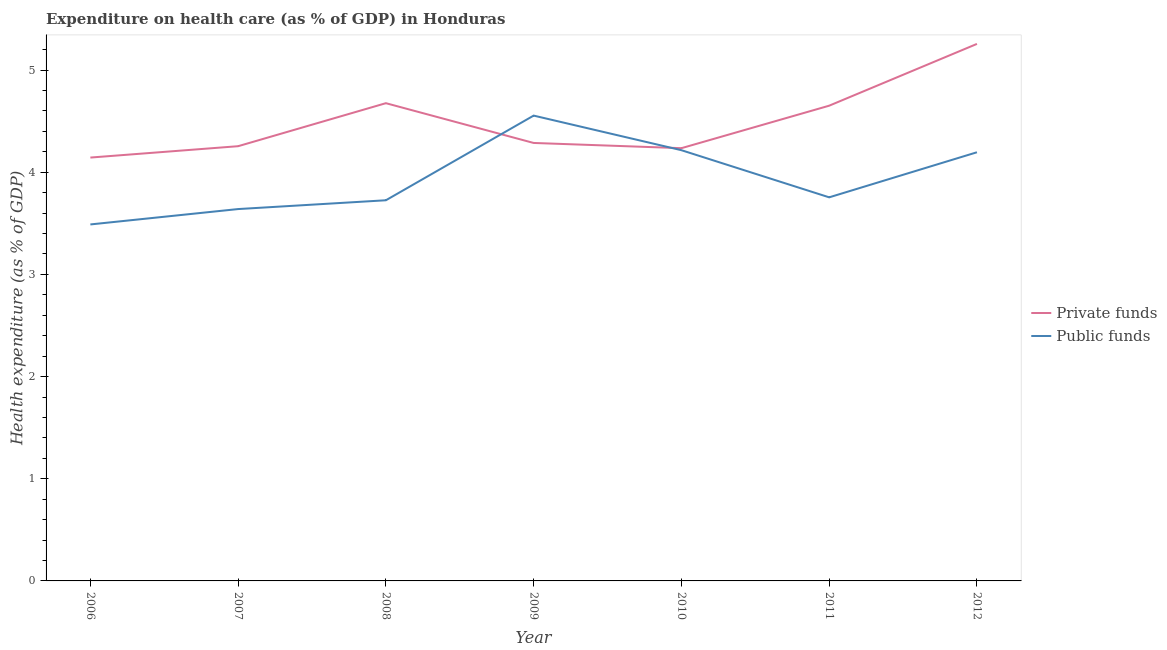How many different coloured lines are there?
Your answer should be compact. 2. Is the number of lines equal to the number of legend labels?
Make the answer very short. Yes. What is the amount of public funds spent in healthcare in 2011?
Ensure brevity in your answer.  3.75. Across all years, what is the maximum amount of public funds spent in healthcare?
Your response must be concise. 4.55. Across all years, what is the minimum amount of public funds spent in healthcare?
Keep it short and to the point. 3.49. In which year was the amount of public funds spent in healthcare maximum?
Ensure brevity in your answer.  2009. What is the total amount of public funds spent in healthcare in the graph?
Offer a terse response. 27.57. What is the difference between the amount of private funds spent in healthcare in 2009 and that in 2012?
Give a very brief answer. -0.97. What is the difference between the amount of private funds spent in healthcare in 2012 and the amount of public funds spent in healthcare in 2008?
Your answer should be very brief. 1.53. What is the average amount of public funds spent in healthcare per year?
Provide a short and direct response. 3.94. In the year 2007, what is the difference between the amount of public funds spent in healthcare and amount of private funds spent in healthcare?
Offer a terse response. -0.62. In how many years, is the amount of public funds spent in healthcare greater than 3 %?
Offer a terse response. 7. What is the ratio of the amount of public funds spent in healthcare in 2007 to that in 2010?
Make the answer very short. 0.86. What is the difference between the highest and the second highest amount of private funds spent in healthcare?
Offer a very short reply. 0.58. What is the difference between the highest and the lowest amount of private funds spent in healthcare?
Your answer should be compact. 1.11. In how many years, is the amount of public funds spent in healthcare greater than the average amount of public funds spent in healthcare taken over all years?
Provide a succinct answer. 3. Is the amount of private funds spent in healthcare strictly greater than the amount of public funds spent in healthcare over the years?
Offer a terse response. No. What is the difference between two consecutive major ticks on the Y-axis?
Your answer should be compact. 1. Are the values on the major ticks of Y-axis written in scientific E-notation?
Provide a succinct answer. No. Does the graph contain any zero values?
Offer a very short reply. No. What is the title of the graph?
Make the answer very short. Expenditure on health care (as % of GDP) in Honduras. Does "Unregistered firms" appear as one of the legend labels in the graph?
Your answer should be very brief. No. What is the label or title of the Y-axis?
Your answer should be very brief. Health expenditure (as % of GDP). What is the Health expenditure (as % of GDP) in Private funds in 2006?
Your answer should be very brief. 4.14. What is the Health expenditure (as % of GDP) in Public funds in 2006?
Your answer should be very brief. 3.49. What is the Health expenditure (as % of GDP) of Private funds in 2007?
Your answer should be very brief. 4.25. What is the Health expenditure (as % of GDP) in Public funds in 2007?
Your response must be concise. 3.64. What is the Health expenditure (as % of GDP) in Private funds in 2008?
Give a very brief answer. 4.68. What is the Health expenditure (as % of GDP) of Public funds in 2008?
Provide a succinct answer. 3.73. What is the Health expenditure (as % of GDP) in Private funds in 2009?
Provide a short and direct response. 4.29. What is the Health expenditure (as % of GDP) in Public funds in 2009?
Give a very brief answer. 4.55. What is the Health expenditure (as % of GDP) in Private funds in 2010?
Your answer should be compact. 4.24. What is the Health expenditure (as % of GDP) in Public funds in 2010?
Give a very brief answer. 4.22. What is the Health expenditure (as % of GDP) of Private funds in 2011?
Your answer should be very brief. 4.65. What is the Health expenditure (as % of GDP) in Public funds in 2011?
Provide a succinct answer. 3.75. What is the Health expenditure (as % of GDP) of Private funds in 2012?
Your answer should be very brief. 5.26. What is the Health expenditure (as % of GDP) of Public funds in 2012?
Your response must be concise. 4.2. Across all years, what is the maximum Health expenditure (as % of GDP) in Private funds?
Your answer should be very brief. 5.26. Across all years, what is the maximum Health expenditure (as % of GDP) of Public funds?
Provide a succinct answer. 4.55. Across all years, what is the minimum Health expenditure (as % of GDP) in Private funds?
Provide a succinct answer. 4.14. Across all years, what is the minimum Health expenditure (as % of GDP) in Public funds?
Provide a short and direct response. 3.49. What is the total Health expenditure (as % of GDP) of Private funds in the graph?
Your response must be concise. 31.5. What is the total Health expenditure (as % of GDP) of Public funds in the graph?
Offer a very short reply. 27.57. What is the difference between the Health expenditure (as % of GDP) of Private funds in 2006 and that in 2007?
Your response must be concise. -0.11. What is the difference between the Health expenditure (as % of GDP) of Public funds in 2006 and that in 2007?
Make the answer very short. -0.15. What is the difference between the Health expenditure (as % of GDP) of Private funds in 2006 and that in 2008?
Your answer should be very brief. -0.53. What is the difference between the Health expenditure (as % of GDP) in Public funds in 2006 and that in 2008?
Offer a terse response. -0.24. What is the difference between the Health expenditure (as % of GDP) in Private funds in 2006 and that in 2009?
Your response must be concise. -0.14. What is the difference between the Health expenditure (as % of GDP) of Public funds in 2006 and that in 2009?
Your answer should be very brief. -1.07. What is the difference between the Health expenditure (as % of GDP) in Private funds in 2006 and that in 2010?
Offer a terse response. -0.09. What is the difference between the Health expenditure (as % of GDP) of Public funds in 2006 and that in 2010?
Ensure brevity in your answer.  -0.73. What is the difference between the Health expenditure (as % of GDP) in Private funds in 2006 and that in 2011?
Your response must be concise. -0.51. What is the difference between the Health expenditure (as % of GDP) of Public funds in 2006 and that in 2011?
Provide a succinct answer. -0.27. What is the difference between the Health expenditure (as % of GDP) of Private funds in 2006 and that in 2012?
Make the answer very short. -1.11. What is the difference between the Health expenditure (as % of GDP) of Public funds in 2006 and that in 2012?
Ensure brevity in your answer.  -0.71. What is the difference between the Health expenditure (as % of GDP) of Private funds in 2007 and that in 2008?
Your answer should be compact. -0.42. What is the difference between the Health expenditure (as % of GDP) of Public funds in 2007 and that in 2008?
Give a very brief answer. -0.09. What is the difference between the Health expenditure (as % of GDP) of Private funds in 2007 and that in 2009?
Offer a terse response. -0.03. What is the difference between the Health expenditure (as % of GDP) of Public funds in 2007 and that in 2009?
Your answer should be compact. -0.91. What is the difference between the Health expenditure (as % of GDP) in Private funds in 2007 and that in 2010?
Make the answer very short. 0.02. What is the difference between the Health expenditure (as % of GDP) of Public funds in 2007 and that in 2010?
Your answer should be compact. -0.58. What is the difference between the Health expenditure (as % of GDP) of Private funds in 2007 and that in 2011?
Offer a very short reply. -0.4. What is the difference between the Health expenditure (as % of GDP) of Public funds in 2007 and that in 2011?
Keep it short and to the point. -0.11. What is the difference between the Health expenditure (as % of GDP) of Private funds in 2007 and that in 2012?
Make the answer very short. -1. What is the difference between the Health expenditure (as % of GDP) in Public funds in 2007 and that in 2012?
Provide a short and direct response. -0.56. What is the difference between the Health expenditure (as % of GDP) in Private funds in 2008 and that in 2009?
Ensure brevity in your answer.  0.39. What is the difference between the Health expenditure (as % of GDP) in Public funds in 2008 and that in 2009?
Keep it short and to the point. -0.83. What is the difference between the Health expenditure (as % of GDP) of Private funds in 2008 and that in 2010?
Your answer should be compact. 0.44. What is the difference between the Health expenditure (as % of GDP) of Public funds in 2008 and that in 2010?
Provide a succinct answer. -0.49. What is the difference between the Health expenditure (as % of GDP) of Private funds in 2008 and that in 2011?
Provide a succinct answer. 0.02. What is the difference between the Health expenditure (as % of GDP) of Public funds in 2008 and that in 2011?
Ensure brevity in your answer.  -0.03. What is the difference between the Health expenditure (as % of GDP) in Private funds in 2008 and that in 2012?
Give a very brief answer. -0.58. What is the difference between the Health expenditure (as % of GDP) of Public funds in 2008 and that in 2012?
Your response must be concise. -0.47. What is the difference between the Health expenditure (as % of GDP) of Private funds in 2009 and that in 2010?
Your response must be concise. 0.05. What is the difference between the Health expenditure (as % of GDP) in Public funds in 2009 and that in 2010?
Offer a very short reply. 0.34. What is the difference between the Health expenditure (as % of GDP) in Private funds in 2009 and that in 2011?
Provide a short and direct response. -0.36. What is the difference between the Health expenditure (as % of GDP) in Public funds in 2009 and that in 2011?
Keep it short and to the point. 0.8. What is the difference between the Health expenditure (as % of GDP) of Private funds in 2009 and that in 2012?
Offer a terse response. -0.97. What is the difference between the Health expenditure (as % of GDP) of Public funds in 2009 and that in 2012?
Provide a succinct answer. 0.36. What is the difference between the Health expenditure (as % of GDP) of Private funds in 2010 and that in 2011?
Your answer should be compact. -0.42. What is the difference between the Health expenditure (as % of GDP) in Public funds in 2010 and that in 2011?
Offer a very short reply. 0.46. What is the difference between the Health expenditure (as % of GDP) in Private funds in 2010 and that in 2012?
Offer a very short reply. -1.02. What is the difference between the Health expenditure (as % of GDP) in Public funds in 2010 and that in 2012?
Provide a succinct answer. 0.02. What is the difference between the Health expenditure (as % of GDP) in Private funds in 2011 and that in 2012?
Provide a short and direct response. -0.6. What is the difference between the Health expenditure (as % of GDP) of Public funds in 2011 and that in 2012?
Your answer should be very brief. -0.44. What is the difference between the Health expenditure (as % of GDP) of Private funds in 2006 and the Health expenditure (as % of GDP) of Public funds in 2007?
Provide a short and direct response. 0.5. What is the difference between the Health expenditure (as % of GDP) in Private funds in 2006 and the Health expenditure (as % of GDP) in Public funds in 2008?
Keep it short and to the point. 0.42. What is the difference between the Health expenditure (as % of GDP) in Private funds in 2006 and the Health expenditure (as % of GDP) in Public funds in 2009?
Your response must be concise. -0.41. What is the difference between the Health expenditure (as % of GDP) in Private funds in 2006 and the Health expenditure (as % of GDP) in Public funds in 2010?
Give a very brief answer. -0.07. What is the difference between the Health expenditure (as % of GDP) of Private funds in 2006 and the Health expenditure (as % of GDP) of Public funds in 2011?
Keep it short and to the point. 0.39. What is the difference between the Health expenditure (as % of GDP) of Private funds in 2006 and the Health expenditure (as % of GDP) of Public funds in 2012?
Provide a short and direct response. -0.05. What is the difference between the Health expenditure (as % of GDP) of Private funds in 2007 and the Health expenditure (as % of GDP) of Public funds in 2008?
Provide a succinct answer. 0.53. What is the difference between the Health expenditure (as % of GDP) in Private funds in 2007 and the Health expenditure (as % of GDP) in Public funds in 2009?
Offer a terse response. -0.3. What is the difference between the Health expenditure (as % of GDP) in Private funds in 2007 and the Health expenditure (as % of GDP) in Public funds in 2010?
Keep it short and to the point. 0.04. What is the difference between the Health expenditure (as % of GDP) of Private funds in 2007 and the Health expenditure (as % of GDP) of Public funds in 2011?
Your response must be concise. 0.5. What is the difference between the Health expenditure (as % of GDP) in Private funds in 2007 and the Health expenditure (as % of GDP) in Public funds in 2012?
Make the answer very short. 0.06. What is the difference between the Health expenditure (as % of GDP) of Private funds in 2008 and the Health expenditure (as % of GDP) of Public funds in 2009?
Offer a very short reply. 0.12. What is the difference between the Health expenditure (as % of GDP) of Private funds in 2008 and the Health expenditure (as % of GDP) of Public funds in 2010?
Your answer should be compact. 0.46. What is the difference between the Health expenditure (as % of GDP) of Private funds in 2008 and the Health expenditure (as % of GDP) of Public funds in 2011?
Keep it short and to the point. 0.92. What is the difference between the Health expenditure (as % of GDP) of Private funds in 2008 and the Health expenditure (as % of GDP) of Public funds in 2012?
Offer a very short reply. 0.48. What is the difference between the Health expenditure (as % of GDP) in Private funds in 2009 and the Health expenditure (as % of GDP) in Public funds in 2010?
Keep it short and to the point. 0.07. What is the difference between the Health expenditure (as % of GDP) in Private funds in 2009 and the Health expenditure (as % of GDP) in Public funds in 2011?
Give a very brief answer. 0.53. What is the difference between the Health expenditure (as % of GDP) in Private funds in 2009 and the Health expenditure (as % of GDP) in Public funds in 2012?
Your answer should be very brief. 0.09. What is the difference between the Health expenditure (as % of GDP) of Private funds in 2010 and the Health expenditure (as % of GDP) of Public funds in 2011?
Your answer should be compact. 0.48. What is the difference between the Health expenditure (as % of GDP) of Private funds in 2010 and the Health expenditure (as % of GDP) of Public funds in 2012?
Make the answer very short. 0.04. What is the difference between the Health expenditure (as % of GDP) in Private funds in 2011 and the Health expenditure (as % of GDP) in Public funds in 2012?
Provide a succinct answer. 0.46. What is the average Health expenditure (as % of GDP) in Private funds per year?
Provide a succinct answer. 4.5. What is the average Health expenditure (as % of GDP) in Public funds per year?
Make the answer very short. 3.94. In the year 2006, what is the difference between the Health expenditure (as % of GDP) of Private funds and Health expenditure (as % of GDP) of Public funds?
Provide a short and direct response. 0.65. In the year 2007, what is the difference between the Health expenditure (as % of GDP) of Private funds and Health expenditure (as % of GDP) of Public funds?
Give a very brief answer. 0.62. In the year 2008, what is the difference between the Health expenditure (as % of GDP) in Private funds and Health expenditure (as % of GDP) in Public funds?
Provide a short and direct response. 0.95. In the year 2009, what is the difference between the Health expenditure (as % of GDP) in Private funds and Health expenditure (as % of GDP) in Public funds?
Make the answer very short. -0.27. In the year 2010, what is the difference between the Health expenditure (as % of GDP) in Private funds and Health expenditure (as % of GDP) in Public funds?
Make the answer very short. 0.02. In the year 2011, what is the difference between the Health expenditure (as % of GDP) in Private funds and Health expenditure (as % of GDP) in Public funds?
Make the answer very short. 0.9. In the year 2012, what is the difference between the Health expenditure (as % of GDP) of Private funds and Health expenditure (as % of GDP) of Public funds?
Make the answer very short. 1.06. What is the ratio of the Health expenditure (as % of GDP) in Private funds in 2006 to that in 2007?
Offer a terse response. 0.97. What is the ratio of the Health expenditure (as % of GDP) in Public funds in 2006 to that in 2007?
Provide a short and direct response. 0.96. What is the ratio of the Health expenditure (as % of GDP) of Private funds in 2006 to that in 2008?
Ensure brevity in your answer.  0.89. What is the ratio of the Health expenditure (as % of GDP) of Public funds in 2006 to that in 2008?
Provide a succinct answer. 0.94. What is the ratio of the Health expenditure (as % of GDP) in Private funds in 2006 to that in 2009?
Your answer should be compact. 0.97. What is the ratio of the Health expenditure (as % of GDP) of Public funds in 2006 to that in 2009?
Your answer should be compact. 0.77. What is the ratio of the Health expenditure (as % of GDP) of Private funds in 2006 to that in 2010?
Your answer should be compact. 0.98. What is the ratio of the Health expenditure (as % of GDP) in Public funds in 2006 to that in 2010?
Your answer should be compact. 0.83. What is the ratio of the Health expenditure (as % of GDP) of Private funds in 2006 to that in 2011?
Provide a succinct answer. 0.89. What is the ratio of the Health expenditure (as % of GDP) of Public funds in 2006 to that in 2011?
Your answer should be compact. 0.93. What is the ratio of the Health expenditure (as % of GDP) of Private funds in 2006 to that in 2012?
Provide a succinct answer. 0.79. What is the ratio of the Health expenditure (as % of GDP) in Public funds in 2006 to that in 2012?
Your answer should be very brief. 0.83. What is the ratio of the Health expenditure (as % of GDP) of Private funds in 2007 to that in 2008?
Your response must be concise. 0.91. What is the ratio of the Health expenditure (as % of GDP) in Public funds in 2007 to that in 2008?
Your answer should be compact. 0.98. What is the ratio of the Health expenditure (as % of GDP) of Private funds in 2007 to that in 2009?
Your answer should be very brief. 0.99. What is the ratio of the Health expenditure (as % of GDP) in Public funds in 2007 to that in 2009?
Your answer should be very brief. 0.8. What is the ratio of the Health expenditure (as % of GDP) of Private funds in 2007 to that in 2010?
Your response must be concise. 1. What is the ratio of the Health expenditure (as % of GDP) in Public funds in 2007 to that in 2010?
Offer a terse response. 0.86. What is the ratio of the Health expenditure (as % of GDP) of Private funds in 2007 to that in 2011?
Make the answer very short. 0.91. What is the ratio of the Health expenditure (as % of GDP) of Public funds in 2007 to that in 2011?
Your response must be concise. 0.97. What is the ratio of the Health expenditure (as % of GDP) of Private funds in 2007 to that in 2012?
Offer a very short reply. 0.81. What is the ratio of the Health expenditure (as % of GDP) in Public funds in 2007 to that in 2012?
Your answer should be very brief. 0.87. What is the ratio of the Health expenditure (as % of GDP) in Private funds in 2008 to that in 2009?
Provide a succinct answer. 1.09. What is the ratio of the Health expenditure (as % of GDP) in Public funds in 2008 to that in 2009?
Offer a terse response. 0.82. What is the ratio of the Health expenditure (as % of GDP) in Private funds in 2008 to that in 2010?
Make the answer very short. 1.1. What is the ratio of the Health expenditure (as % of GDP) of Public funds in 2008 to that in 2010?
Keep it short and to the point. 0.88. What is the ratio of the Health expenditure (as % of GDP) in Private funds in 2008 to that in 2011?
Give a very brief answer. 1.01. What is the ratio of the Health expenditure (as % of GDP) in Private funds in 2008 to that in 2012?
Ensure brevity in your answer.  0.89. What is the ratio of the Health expenditure (as % of GDP) of Public funds in 2008 to that in 2012?
Keep it short and to the point. 0.89. What is the ratio of the Health expenditure (as % of GDP) of Private funds in 2009 to that in 2010?
Provide a succinct answer. 1.01. What is the ratio of the Health expenditure (as % of GDP) in Public funds in 2009 to that in 2010?
Make the answer very short. 1.08. What is the ratio of the Health expenditure (as % of GDP) in Private funds in 2009 to that in 2011?
Make the answer very short. 0.92. What is the ratio of the Health expenditure (as % of GDP) of Public funds in 2009 to that in 2011?
Offer a terse response. 1.21. What is the ratio of the Health expenditure (as % of GDP) of Private funds in 2009 to that in 2012?
Your response must be concise. 0.82. What is the ratio of the Health expenditure (as % of GDP) in Public funds in 2009 to that in 2012?
Provide a succinct answer. 1.09. What is the ratio of the Health expenditure (as % of GDP) of Private funds in 2010 to that in 2011?
Offer a terse response. 0.91. What is the ratio of the Health expenditure (as % of GDP) in Public funds in 2010 to that in 2011?
Make the answer very short. 1.12. What is the ratio of the Health expenditure (as % of GDP) of Private funds in 2010 to that in 2012?
Your answer should be very brief. 0.81. What is the ratio of the Health expenditure (as % of GDP) of Public funds in 2010 to that in 2012?
Give a very brief answer. 1. What is the ratio of the Health expenditure (as % of GDP) in Private funds in 2011 to that in 2012?
Offer a very short reply. 0.88. What is the ratio of the Health expenditure (as % of GDP) of Public funds in 2011 to that in 2012?
Your answer should be very brief. 0.89. What is the difference between the highest and the second highest Health expenditure (as % of GDP) in Private funds?
Your response must be concise. 0.58. What is the difference between the highest and the second highest Health expenditure (as % of GDP) in Public funds?
Provide a short and direct response. 0.34. What is the difference between the highest and the lowest Health expenditure (as % of GDP) of Private funds?
Provide a short and direct response. 1.11. What is the difference between the highest and the lowest Health expenditure (as % of GDP) in Public funds?
Your answer should be compact. 1.07. 